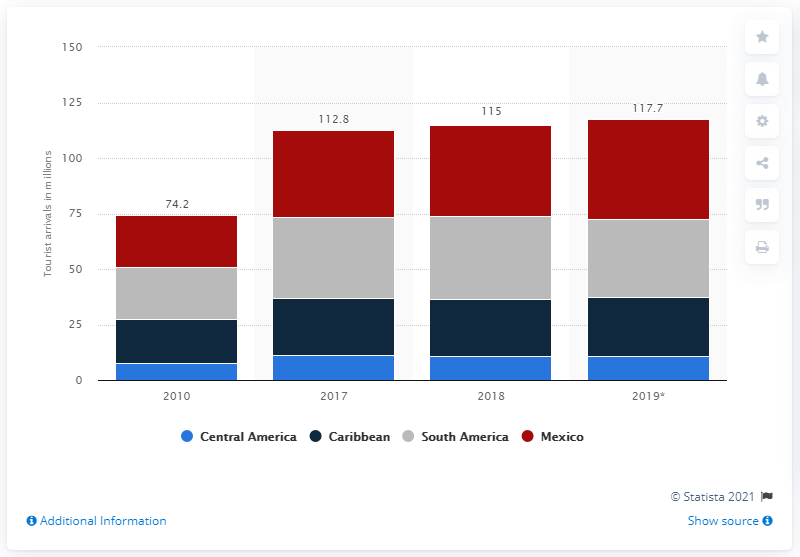Highlight a few significant elements in this photo. Mexico is the country that accounts for more than one third of the international tourism volume in Latin America. In 2018, South America experienced a slight reversal compared to the previous year. 